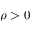<formula> <loc_0><loc_0><loc_500><loc_500>\rho > 0</formula> 